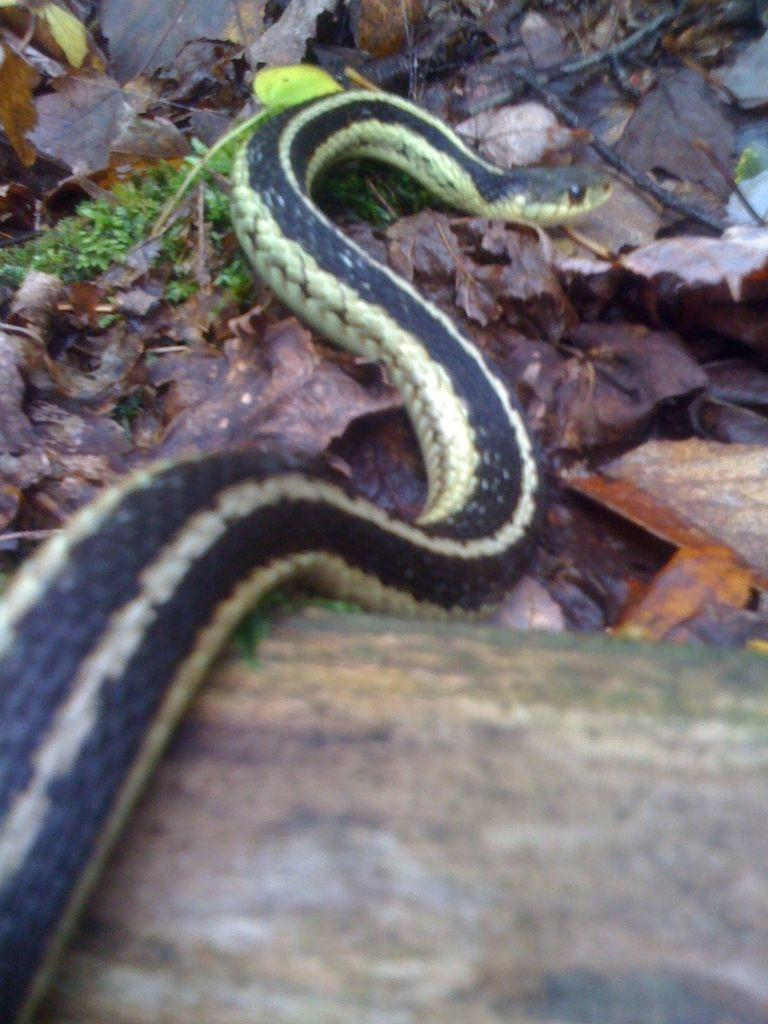What animal can be seen on the ground in the image? There is a snake on the ground in the image. What type of object is present in the image? There is a wooden log in the image. What type of vegetation is visible in the image? There are dried leaves in the image. What color of paint is being used on the fire hydrant in the image? There is no fire hydrant present in the image, so it is not possible to determine the color of paint being used. 